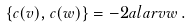<formula> <loc_0><loc_0><loc_500><loc_500>\left \{ c ( v ) , c ( w ) \right \} = - 2 a l a r { v } { w } \, .</formula> 